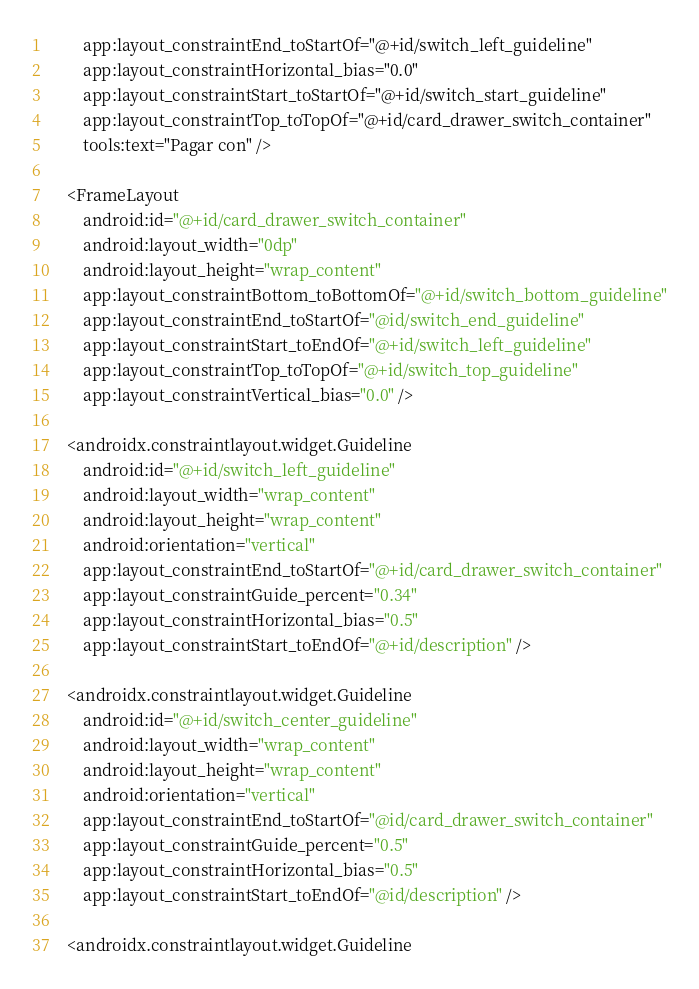Convert code to text. <code><loc_0><loc_0><loc_500><loc_500><_XML_>        app:layout_constraintEnd_toStartOf="@+id/switch_left_guideline"
        app:layout_constraintHorizontal_bias="0.0"
        app:layout_constraintStart_toStartOf="@+id/switch_start_guideline"
        app:layout_constraintTop_toTopOf="@+id/card_drawer_switch_container"
        tools:text="Pagar con" />

    <FrameLayout
        android:id="@+id/card_drawer_switch_container"
        android:layout_width="0dp"
        android:layout_height="wrap_content"
        app:layout_constraintBottom_toBottomOf="@+id/switch_bottom_guideline"
        app:layout_constraintEnd_toStartOf="@id/switch_end_guideline"
        app:layout_constraintStart_toEndOf="@+id/switch_left_guideline"
        app:layout_constraintTop_toTopOf="@+id/switch_top_guideline"
        app:layout_constraintVertical_bias="0.0" />

    <androidx.constraintlayout.widget.Guideline
        android:id="@+id/switch_left_guideline"
        android:layout_width="wrap_content"
        android:layout_height="wrap_content"
        android:orientation="vertical"
        app:layout_constraintEnd_toStartOf="@+id/card_drawer_switch_container"
        app:layout_constraintGuide_percent="0.34"
        app:layout_constraintHorizontal_bias="0.5"
        app:layout_constraintStart_toEndOf="@+id/description" />

    <androidx.constraintlayout.widget.Guideline
        android:id="@+id/switch_center_guideline"
        android:layout_width="wrap_content"
        android:layout_height="wrap_content"
        android:orientation="vertical"
        app:layout_constraintEnd_toStartOf="@id/card_drawer_switch_container"
        app:layout_constraintGuide_percent="0.5"
        app:layout_constraintHorizontal_bias="0.5"
        app:layout_constraintStart_toEndOf="@id/description" />

    <androidx.constraintlayout.widget.Guideline</code> 